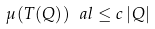<formula> <loc_0><loc_0><loc_500><loc_500>\mu ( T ( Q ) ) ^ { \ } a l \leq c \, | Q |</formula> 